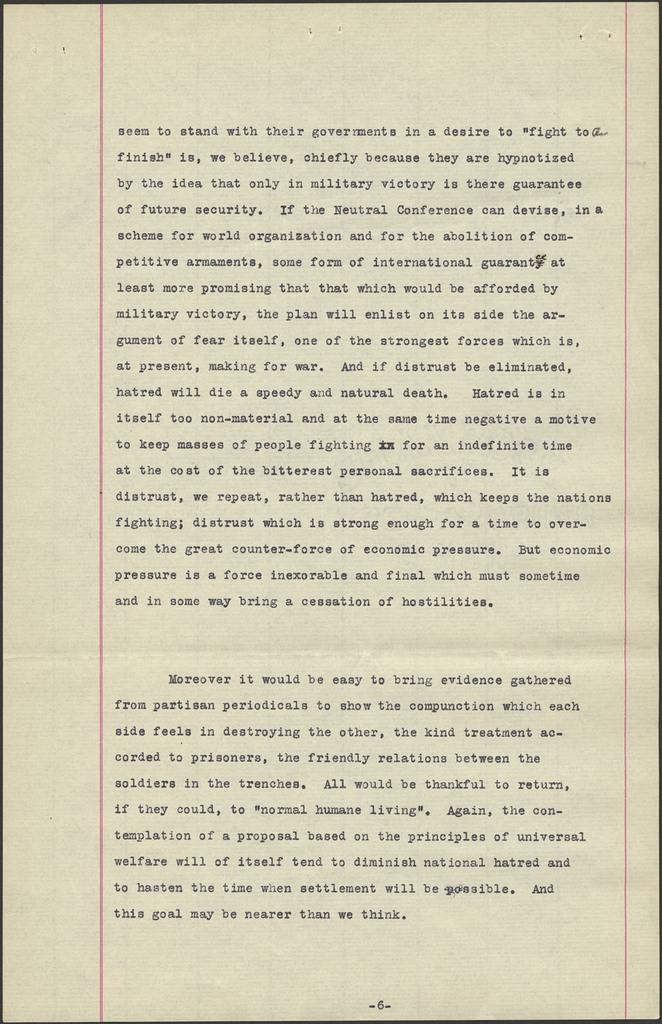<image>
Describe the image concisely. A piece of notebook paper with the first line stating "Seem to stand with their government in a desire..." 